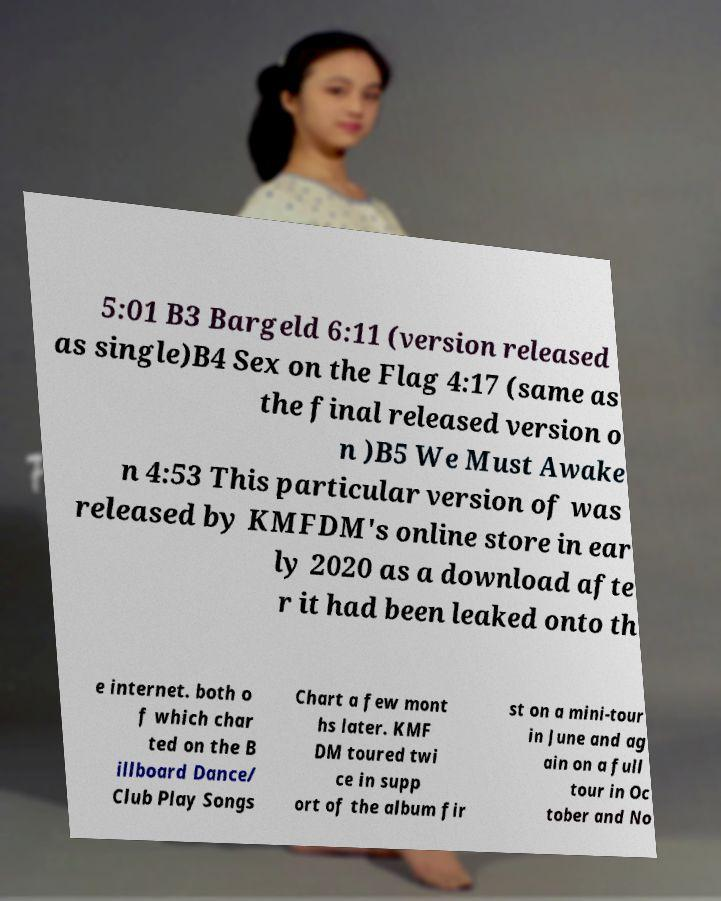Can you read and provide the text displayed in the image?This photo seems to have some interesting text. Can you extract and type it out for me? 5:01 B3 Bargeld 6:11 (version released as single)B4 Sex on the Flag 4:17 (same as the final released version o n )B5 We Must Awake n 4:53 This particular version of was released by KMFDM's online store in ear ly 2020 as a download afte r it had been leaked onto th e internet. both o f which char ted on the B illboard Dance/ Club Play Songs Chart a few mont hs later. KMF DM toured twi ce in supp ort of the album fir st on a mini-tour in June and ag ain on a full tour in Oc tober and No 